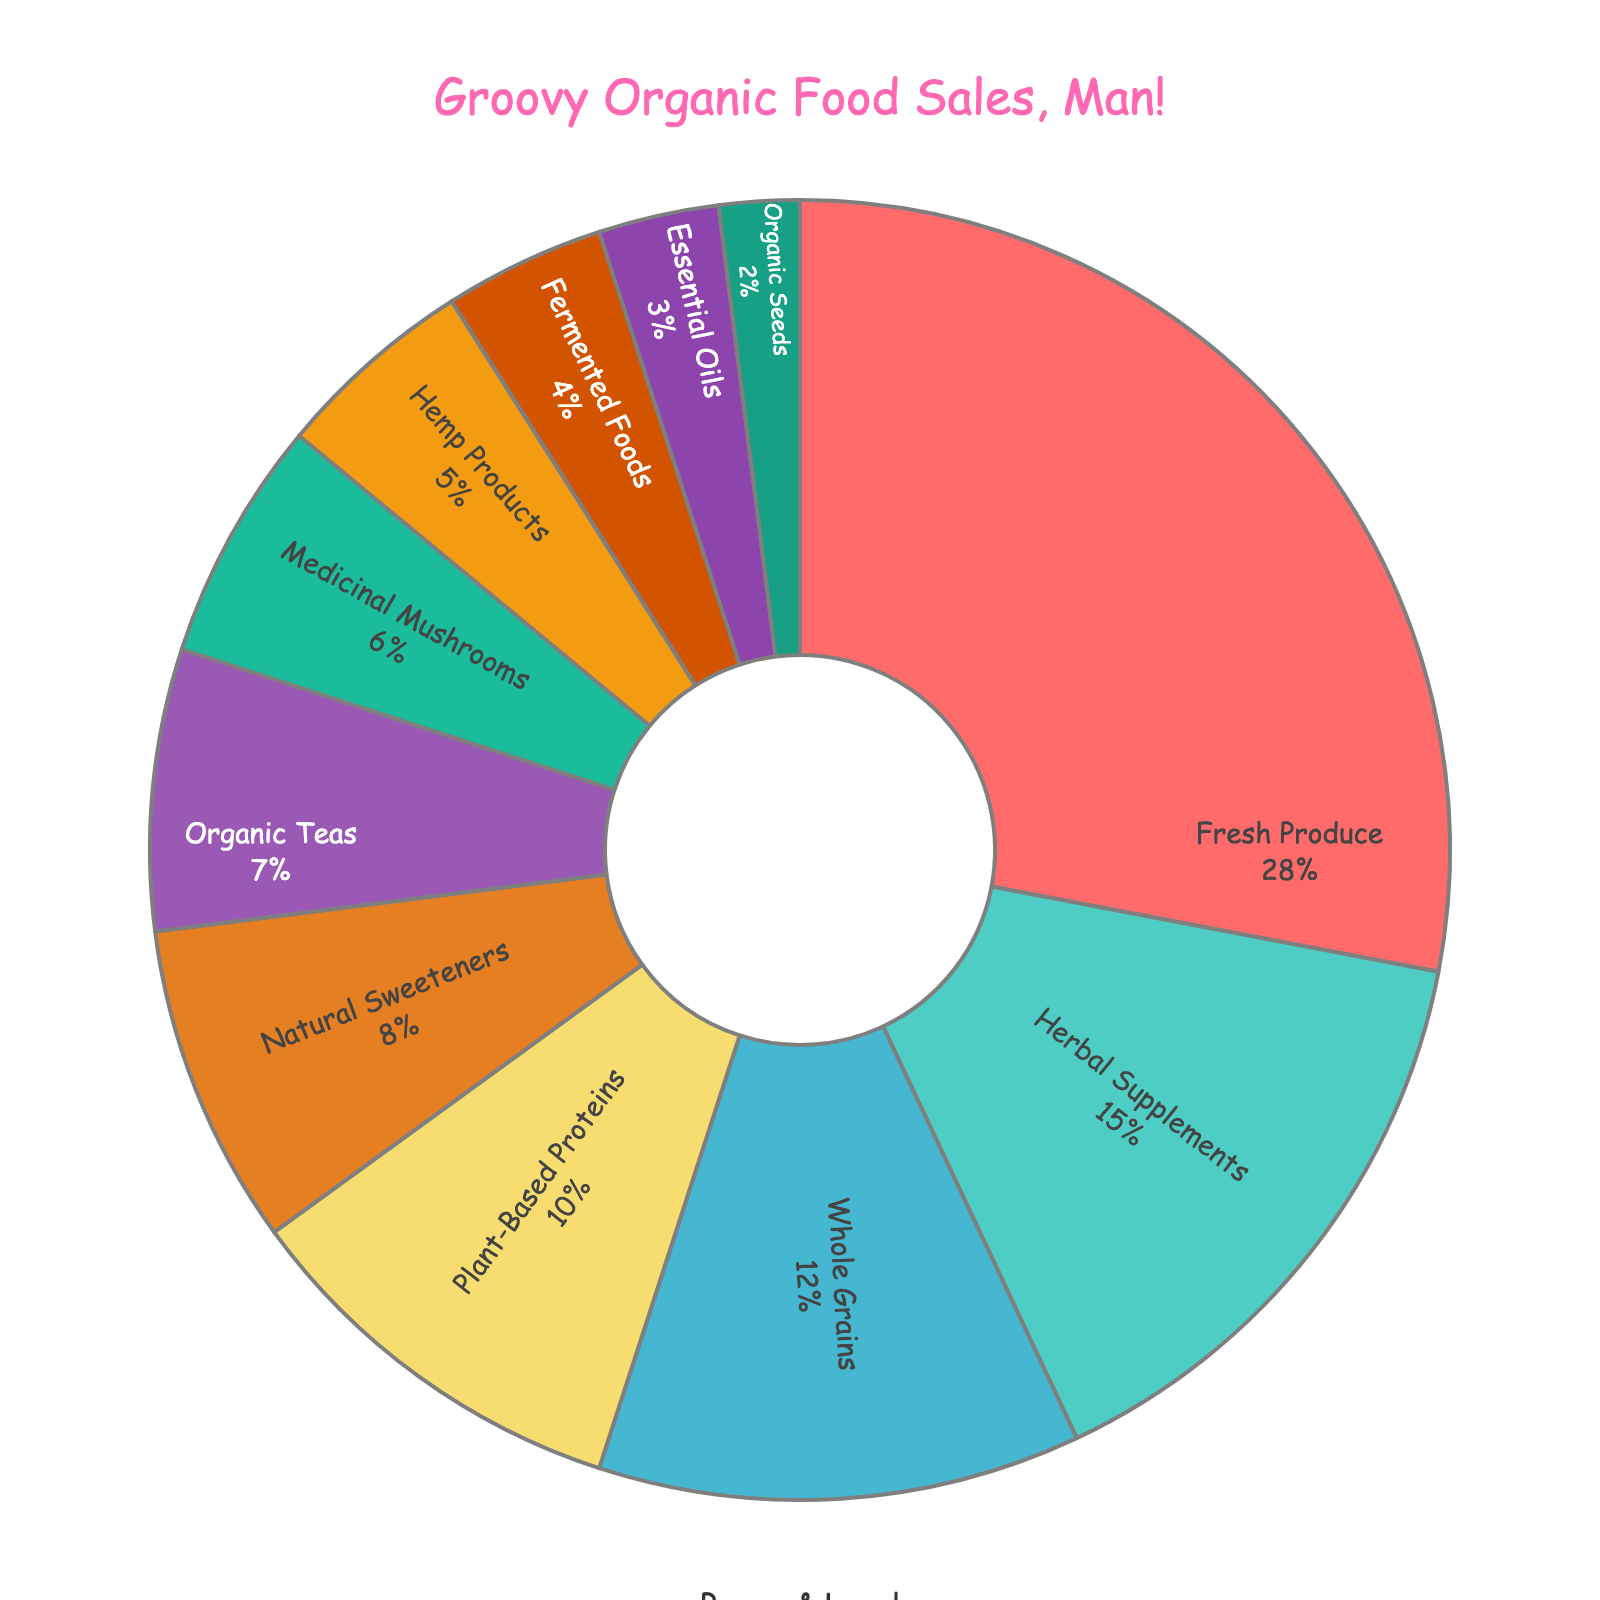Which category has the largest percentage of sales? Look at the categories listed and their corresponding percentages; identify the one with the highest value. Fresh Produce has the highest percentage at 28%.
Answer: Fresh Produce Which three categories together make up over half of the sales? Add up the percentages of the highest values until the sum is over 50%. Fresh Produce (28%), Herbal Supplements (15%), and Whole Grains (12%) together make 55%.
Answer: Fresh Produce, Herbal Supplements, Whole Grains How much larger is Fresh Produce compared to Plant-Based Proteins? Subtract the percentage of Plant-Based Proteins from Fresh Produce. Fresh Produce is 28% and Plant-Based Proteins is 10%. The difference is 28% - 10% = 18%.
Answer: 18% Which category has the smallest share of sales? Find the category with the lowest percentage. Organic Seeds has the lowest percentage at 2%.
Answer: Organic Seeds What is the combined percentage of Organic Teas and Medicinal Mushrooms? Add the percentages of Organic Teas and Medicinal Mushrooms. Organic Teas is 7% and Medicinal Mushrooms is 6%. The combined percentage is 7% + 6% = 13%.
Answer: 13% Is the percentage of Herbal Supplements greater than twice the percentage of Essential Oils? Calculate twice the percentage of Essential Oils and compare it to Herbal Supplements. Twice the percentage of Essential Oils is 3% * 2 = 6%. Herbal Supplements is 15%, which is greater than 6%.
Answer: Yes What is the difference between the percentages of Whole Grains and Natural Sweeteners? Subtract the percentage of Natural Sweeteners from Whole Grains. Whole Grains is 12% and Natural Sweeteners is 8%. The difference is 12% - 8% = 4%.
Answer: 4% Do Plant-Based Proteins and Natural Sweeteners together account for more or less than Herbal Supplements alone? Add the percentages of Plant-Based Proteins and Natural Sweeteners and compare to Herbal Supplements. Plant-Based Proteins and Natural Sweeteners together is 10% + 8% = 18%. Herbal Supplements alone is 15%. 18% is greater than 15%.
Answer: More What is the total percentage of sales that are not part of Fresh Produce and Herbal Supplements? Subtract the combined percentage of Fresh Produce and Herbal Supplements from 100%. Fresh Produce is 28% and Herbal Supplements is 15%. Their sum is 28% + 15% = 43%. 100% - 43% = 57%.
Answer: 57% 